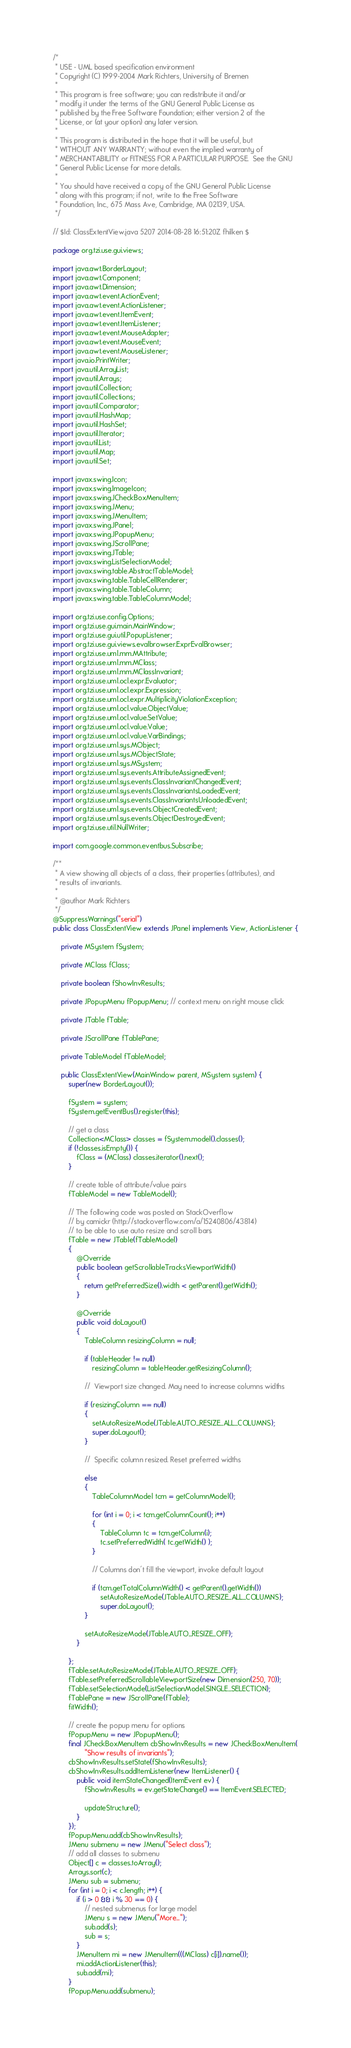<code> <loc_0><loc_0><loc_500><loc_500><_Java_>/*
 * USE - UML based specification environment
 * Copyright (C) 1999-2004 Mark Richters, University of Bremen
 *
 * This program is free software; you can redistribute it and/or
 * modify it under the terms of the GNU General Public License as
 * published by the Free Software Foundation; either version 2 of the
 * License, or (at your option) any later version.
 *
 * This program is distributed in the hope that it will be useful, but
 * WITHOUT ANY WARRANTY; without even the implied warranty of
 * MERCHANTABILITY or FITNESS FOR A PARTICULAR PURPOSE.  See the GNU
 * General Public License for more details.
 *
 * You should have received a copy of the GNU General Public License
 * along with this program; if not, write to the Free Software
 * Foundation, Inc., 675 Mass Ave, Cambridge, MA 02139, USA.
 */

// $Id: ClassExtentView.java 5207 2014-08-28 16:51:20Z fhilken $

package org.tzi.use.gui.views;

import java.awt.BorderLayout;
import java.awt.Component;
import java.awt.Dimension;
import java.awt.event.ActionEvent;
import java.awt.event.ActionListener;
import java.awt.event.ItemEvent;
import java.awt.event.ItemListener;
import java.awt.event.MouseAdapter;
import java.awt.event.MouseEvent;
import java.awt.event.MouseListener;
import java.io.PrintWriter;
import java.util.ArrayList;
import java.util.Arrays;
import java.util.Collection;
import java.util.Collections;
import java.util.Comparator;
import java.util.HashMap;
import java.util.HashSet;
import java.util.Iterator;
import java.util.List;
import java.util.Map;
import java.util.Set;

import javax.swing.Icon;
import javax.swing.ImageIcon;
import javax.swing.JCheckBoxMenuItem;
import javax.swing.JMenu;
import javax.swing.JMenuItem;
import javax.swing.JPanel;
import javax.swing.JPopupMenu;
import javax.swing.JScrollPane;
import javax.swing.JTable;
import javax.swing.ListSelectionModel;
import javax.swing.table.AbstractTableModel;
import javax.swing.table.TableCellRenderer;
import javax.swing.table.TableColumn;
import javax.swing.table.TableColumnModel;

import org.tzi.use.config.Options;
import org.tzi.use.gui.main.MainWindow;
import org.tzi.use.gui.util.PopupListener;
import org.tzi.use.gui.views.evalbrowser.ExprEvalBrowser;
import org.tzi.use.uml.mm.MAttribute;
import org.tzi.use.uml.mm.MClass;
import org.tzi.use.uml.mm.MClassInvariant;
import org.tzi.use.uml.ocl.expr.Evaluator;
import org.tzi.use.uml.ocl.expr.Expression;
import org.tzi.use.uml.ocl.expr.MultiplicityViolationException;
import org.tzi.use.uml.ocl.value.ObjectValue;
import org.tzi.use.uml.ocl.value.SetValue;
import org.tzi.use.uml.ocl.value.Value;
import org.tzi.use.uml.ocl.value.VarBindings;
import org.tzi.use.uml.sys.MObject;
import org.tzi.use.uml.sys.MObjectState;
import org.tzi.use.uml.sys.MSystem;
import org.tzi.use.uml.sys.events.AttributeAssignedEvent;
import org.tzi.use.uml.sys.events.ClassInvariantChangedEvent;
import org.tzi.use.uml.sys.events.ClassInvariantsLoadedEvent;
import org.tzi.use.uml.sys.events.ClassInvariantsUnloadedEvent;
import org.tzi.use.uml.sys.events.ObjectCreatedEvent;
import org.tzi.use.uml.sys.events.ObjectDestroyedEvent;
import org.tzi.use.util.NullWriter;

import com.google.common.eventbus.Subscribe;

/**
 * A view showing all objects of a class, their properties (attributes), and
 * results of invariants.
 * 
 * @author Mark Richters
 */
@SuppressWarnings("serial")
public class ClassExtentView extends JPanel implements View, ActionListener {

    private MSystem fSystem;

    private MClass fClass;

    private boolean fShowInvResults;

    private JPopupMenu fPopupMenu; // context menu on right mouse click

    private JTable fTable;

    private JScrollPane fTablePane;

    private TableModel fTableModel;

    public ClassExtentView(MainWindow parent, MSystem system) {
        super(new BorderLayout());

        fSystem = system;
        fSystem.getEventBus().register(this);

        // get a class
        Collection<MClass> classes = fSystem.model().classes();
        if (!classes.isEmpty()) {
            fClass = (MClass) classes.iterator().next();
        }

        // create table of attribute/value pairs
        fTableModel = new TableModel();
        
        // The following code was posted on StackOverflow
        // by camickr (http://stackoverflow.com/a/15240806/43814)
        // to be able to use auto resize and scroll bars
        fTable = new JTable(fTableModel)
        {
            @Override
            public boolean getScrollableTracksViewportWidth()
            {
                return getPreferredSize().width < getParent().getWidth();
            }

            @Override
            public void doLayout()
            {
                TableColumn resizingColumn = null;

                if (tableHeader != null)
                    resizingColumn = tableHeader.getResizingColumn();

                //  Viewport size changed. May need to increase columns widths

                if (resizingColumn == null)
                {
                    setAutoResizeMode(JTable.AUTO_RESIZE_ALL_COLUMNS);
                    super.doLayout();
                }

                //  Specific column resized. Reset preferred widths

                else
                {
                    TableColumnModel tcm = getColumnModel();

                    for (int i = 0; i < tcm.getColumnCount(); i++)
                    {
                        TableColumn tc = tcm.getColumn(i);
                        tc.setPreferredWidth( tc.getWidth() );
                    }

                    // Columns don't fill the viewport, invoke default layout

                    if (tcm.getTotalColumnWidth() < getParent().getWidth())
                        setAutoResizeMode(JTable.AUTO_RESIZE_ALL_COLUMNS);
                        super.doLayout();
                }

                setAutoResizeMode(JTable.AUTO_RESIZE_OFF);
            }

        };
        fTable.setAutoResizeMode(JTable.AUTO_RESIZE_OFF);
        fTable.setPreferredScrollableViewportSize(new Dimension(250, 70));
        fTable.setSelectionMode(ListSelectionModel.SINGLE_SELECTION);
        fTablePane = new JScrollPane(fTable);
        fitWidth();

        // create the popup menu for options
        fPopupMenu = new JPopupMenu();
        final JCheckBoxMenuItem cbShowInvResults = new JCheckBoxMenuItem(
                "Show results of invariants");
        cbShowInvResults.setState(fShowInvResults);
        cbShowInvResults.addItemListener(new ItemListener() {
            public void itemStateChanged(ItemEvent ev) {
                fShowInvResults = ev.getStateChange() == ItemEvent.SELECTED;

                updateStructure();
            }
        });
        fPopupMenu.add(cbShowInvResults);
        JMenu submenu = new JMenu("Select class");
        // add all classes to submenu
        Object[] c = classes.toArray();
        Arrays.sort(c);
        JMenu sub = submenu;
        for (int i = 0; i < c.length; i++) {
            if (i > 0 && i % 30 == 0) {
                // nested submenus for large model
                JMenu s = new JMenu("More...");
                sub.add(s);
                sub = s;
            }
            JMenuItem mi = new JMenuItem(((MClass) c[i]).name());
            mi.addActionListener(this);
            sub.add(mi);
        }
        fPopupMenu.add(submenu);</code> 